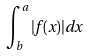Convert formula to latex. <formula><loc_0><loc_0><loc_500><loc_500>\int _ { b } ^ { a } | f ( x ) | d x</formula> 